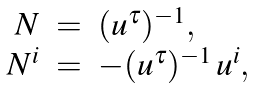Convert formula to latex. <formula><loc_0><loc_0><loc_500><loc_500>\begin{array} { r c l } N & = & { ( u ^ { \tau } ) ^ { - 1 } } , \\ N ^ { i } & = & - ( u ^ { \tau } ) ^ { - 1 } \, { u ^ { i } } , \\ \end{array}</formula> 